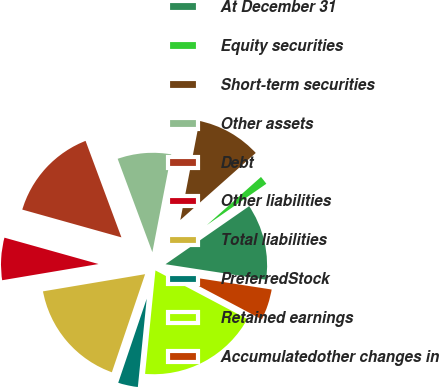Convert chart to OTSL. <chart><loc_0><loc_0><loc_500><loc_500><pie_chart><fcel>At December 31<fcel>Equity securities<fcel>Short-term securities<fcel>Other assets<fcel>Debt<fcel>Other liabilities<fcel>Total liabilities<fcel>PreferredStock<fcel>Retained earnings<fcel>Accumulatedother changes in<nl><fcel>12.09%<fcel>1.91%<fcel>10.4%<fcel>8.7%<fcel>14.99%<fcel>7.0%<fcel>17.15%<fcel>3.61%<fcel>18.85%<fcel>5.31%<nl></chart> 